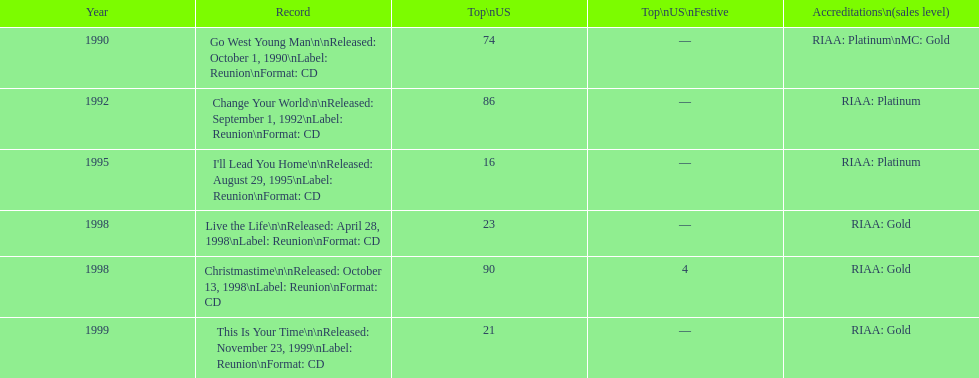What was the first michael w smith album? Go West Young Man. 